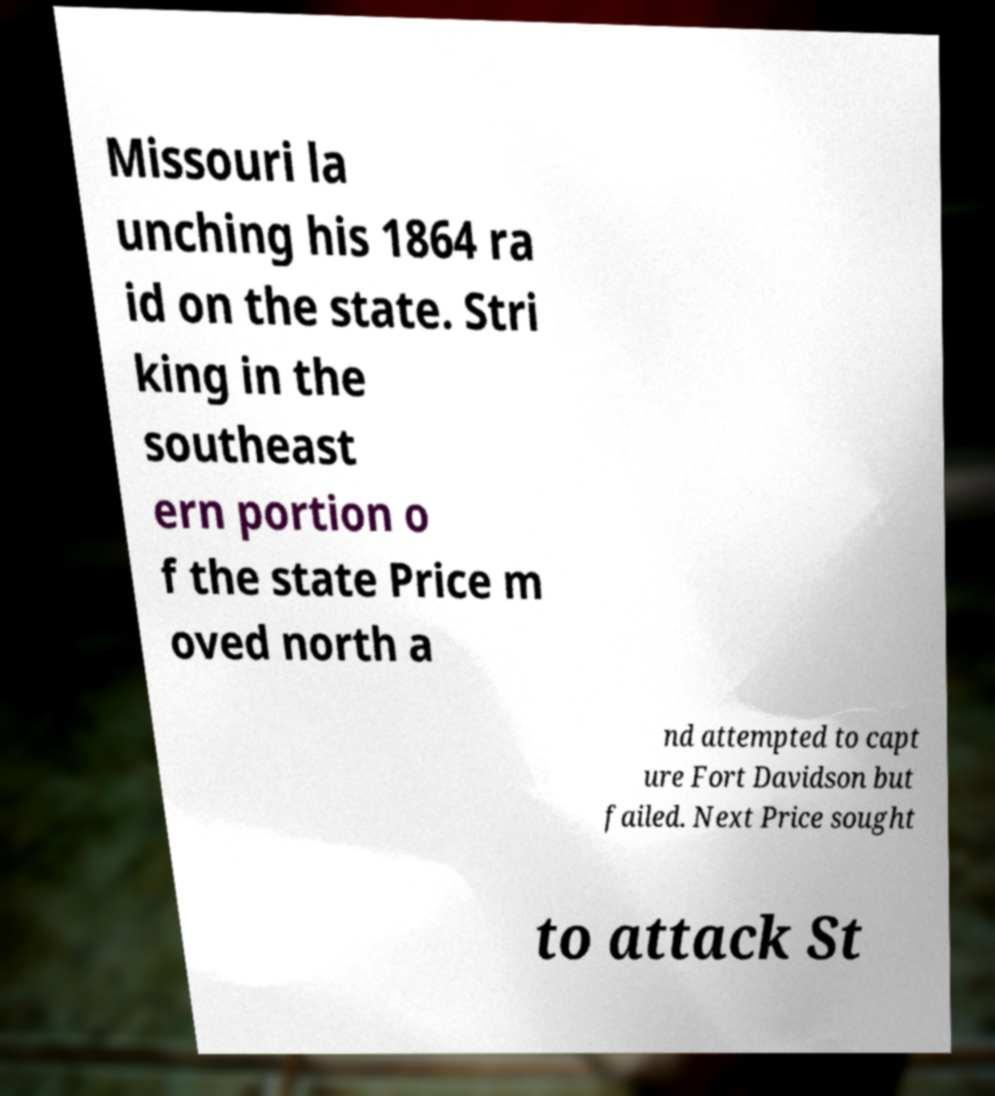For documentation purposes, I need the text within this image transcribed. Could you provide that? Missouri la unching his 1864 ra id on the state. Stri king in the southeast ern portion o f the state Price m oved north a nd attempted to capt ure Fort Davidson but failed. Next Price sought to attack St 